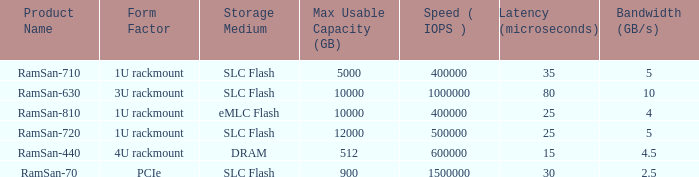List the range distroration for the ramsan-630 3U rackmount. 